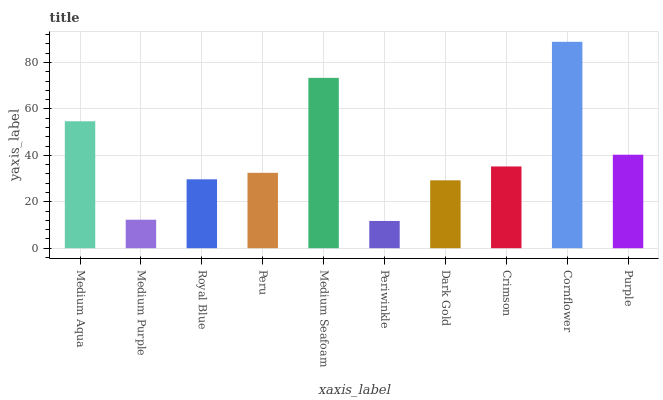Is Medium Purple the minimum?
Answer yes or no. No. Is Medium Purple the maximum?
Answer yes or no. No. Is Medium Aqua greater than Medium Purple?
Answer yes or no. Yes. Is Medium Purple less than Medium Aqua?
Answer yes or no. Yes. Is Medium Purple greater than Medium Aqua?
Answer yes or no. No. Is Medium Aqua less than Medium Purple?
Answer yes or no. No. Is Crimson the high median?
Answer yes or no. Yes. Is Peru the low median?
Answer yes or no. Yes. Is Medium Seafoam the high median?
Answer yes or no. No. Is Dark Gold the low median?
Answer yes or no. No. 